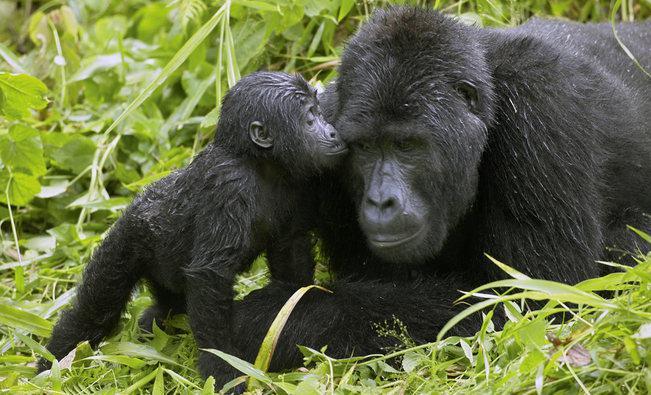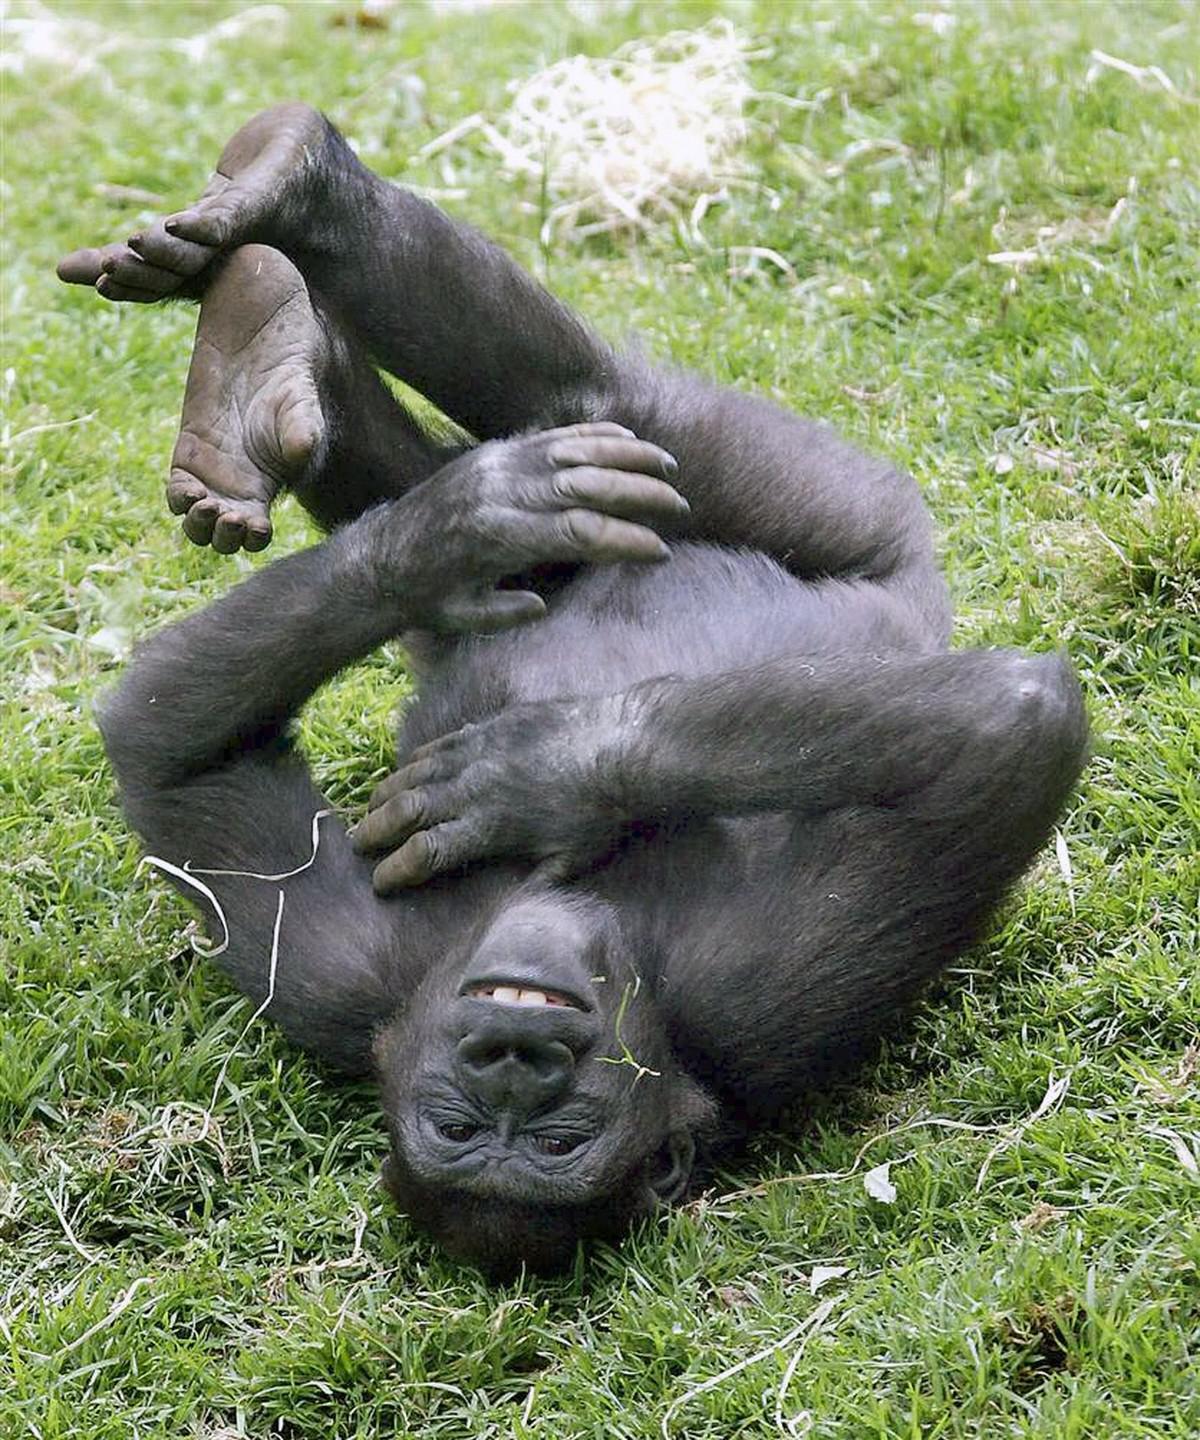The first image is the image on the left, the second image is the image on the right. Evaluate the accuracy of this statement regarding the images: "One image shows a single ape lying upside-down on its back, with the top of its head facing the camera.". Is it true? Answer yes or no. Yes. The first image is the image on the left, the second image is the image on the right. Examine the images to the left and right. Is the description "The right image contains exactly one gorilla laying on its back surrounded by green foliage." accurate? Answer yes or no. Yes. 